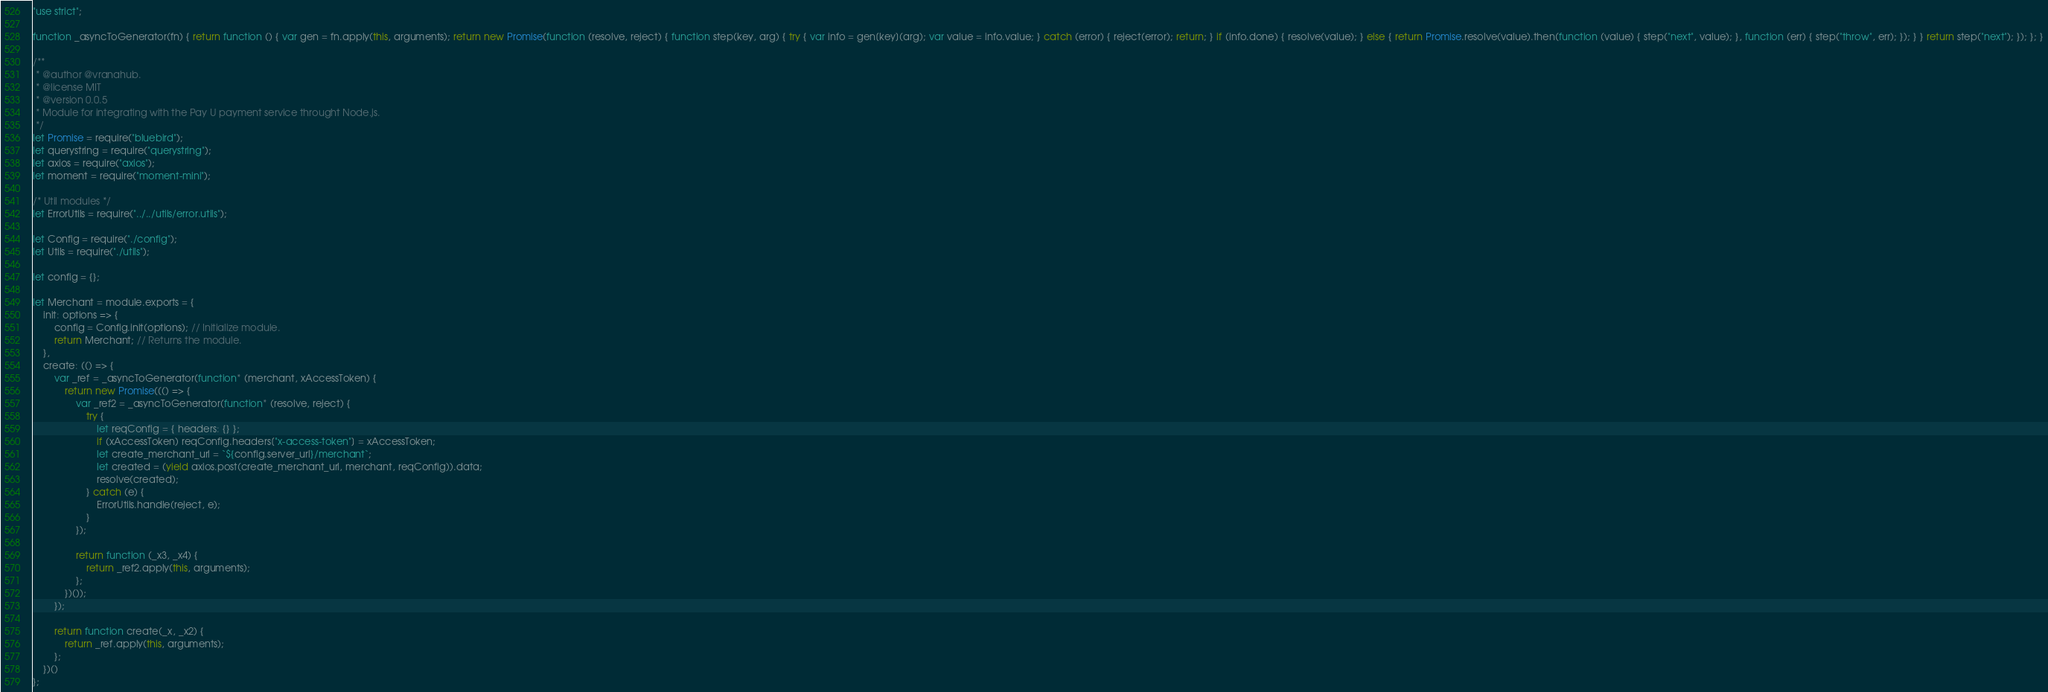Convert code to text. <code><loc_0><loc_0><loc_500><loc_500><_JavaScript_>"use strict";

function _asyncToGenerator(fn) { return function () { var gen = fn.apply(this, arguments); return new Promise(function (resolve, reject) { function step(key, arg) { try { var info = gen[key](arg); var value = info.value; } catch (error) { reject(error); return; } if (info.done) { resolve(value); } else { return Promise.resolve(value).then(function (value) { step("next", value); }, function (err) { step("throw", err); }); } } return step("next"); }); }; }

/**
 * @author @vranahub.
 * @license MIT
 * @version 0.0.5
 * Module for integrating with the Pay U payment service throught Node.js.
 */
let Promise = require("bluebird");
let querystring = require("querystring");
let axios = require("axios");
let moment = require("moment-mini");

/* Util modules */
let ErrorUtils = require("../../utils/error.utils");

let Config = require("./config");
let Utils = require("./utils");

let config = {};

let Merchant = module.exports = {
    init: options => {
        config = Config.init(options); // Initialize module.
        return Merchant; // Returns the module.
    },
    create: (() => {
        var _ref = _asyncToGenerator(function* (merchant, xAccessToken) {
            return new Promise((() => {
                var _ref2 = _asyncToGenerator(function* (resolve, reject) {
                    try {
                        let reqConfig = { headers: {} };
                        if (xAccessToken) reqConfig.headers["x-access-token"] = xAccessToken;
                        let create_merchant_url = `${config.server_url}/merchant`;
                        let created = (yield axios.post(create_merchant_url, merchant, reqConfig)).data;
                        resolve(created);
                    } catch (e) {
                        ErrorUtils.handle(reject, e);
                    }
                });

                return function (_x3, _x4) {
                    return _ref2.apply(this, arguments);
                };
            })());
        });

        return function create(_x, _x2) {
            return _ref.apply(this, arguments);
        };
    })()
};</code> 